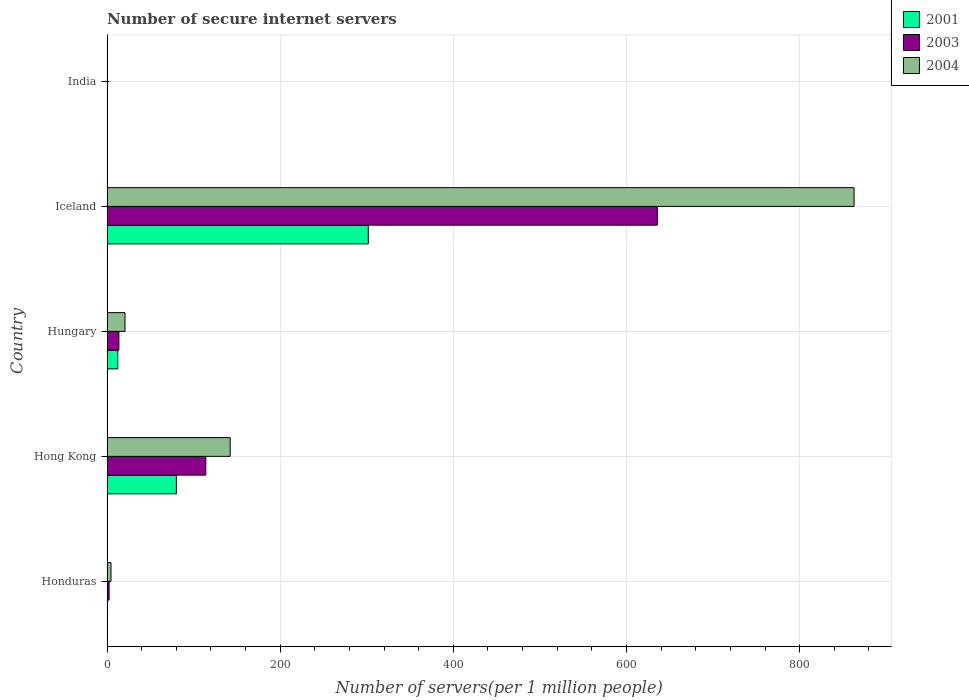Are the number of bars per tick equal to the number of legend labels?
Your response must be concise. Yes. Are the number of bars on each tick of the Y-axis equal?
Make the answer very short. Yes. How many bars are there on the 2nd tick from the bottom?
Your response must be concise. 3. What is the label of the 4th group of bars from the top?
Your answer should be very brief. Hong Kong. What is the number of secure internet servers in 2001 in Hong Kong?
Offer a very short reply. 80.13. Across all countries, what is the maximum number of secure internet servers in 2004?
Offer a terse response. 862.8. Across all countries, what is the minimum number of secure internet servers in 2003?
Make the answer very short. 0.25. In which country was the number of secure internet servers in 2003 maximum?
Provide a succinct answer. Iceland. What is the total number of secure internet servers in 2004 in the graph?
Your answer should be very brief. 1030.83. What is the difference between the number of secure internet servers in 2001 in Hungary and that in India?
Provide a short and direct response. 12.35. What is the difference between the number of secure internet servers in 2004 in India and the number of secure internet servers in 2001 in Iceland?
Give a very brief answer. -301.38. What is the average number of secure internet servers in 2004 per country?
Give a very brief answer. 206.17. What is the difference between the number of secure internet servers in 2003 and number of secure internet servers in 2001 in Iceland?
Provide a short and direct response. 333.74. What is the ratio of the number of secure internet servers in 2001 in Honduras to that in Hungary?
Provide a succinct answer. 0.05. What is the difference between the highest and the second highest number of secure internet servers in 2001?
Keep it short and to the point. 221.66. What is the difference between the highest and the lowest number of secure internet servers in 2003?
Your answer should be very brief. 635.28. In how many countries, is the number of secure internet servers in 2001 greater than the average number of secure internet servers in 2001 taken over all countries?
Ensure brevity in your answer.  2. Is it the case that in every country, the sum of the number of secure internet servers in 2003 and number of secure internet servers in 2004 is greater than the number of secure internet servers in 2001?
Keep it short and to the point. Yes. Are all the bars in the graph horizontal?
Offer a terse response. Yes. What is the difference between two consecutive major ticks on the X-axis?
Your answer should be compact. 200. Are the values on the major ticks of X-axis written in scientific E-notation?
Provide a short and direct response. No. Does the graph contain any zero values?
Your answer should be compact. No. Where does the legend appear in the graph?
Your answer should be compact. Top right. How many legend labels are there?
Your answer should be very brief. 3. How are the legend labels stacked?
Offer a terse response. Vertical. What is the title of the graph?
Provide a short and direct response. Number of secure internet servers. Does "1970" appear as one of the legend labels in the graph?
Provide a short and direct response. No. What is the label or title of the X-axis?
Offer a very short reply. Number of servers(per 1 million people). What is the label or title of the Y-axis?
Make the answer very short. Country. What is the Number of servers(per 1 million people) of 2001 in Honduras?
Offer a very short reply. 0.63. What is the Number of servers(per 1 million people) of 2003 in Honduras?
Give a very brief answer. 2.41. What is the Number of servers(per 1 million people) of 2004 in Honduras?
Your answer should be compact. 4.59. What is the Number of servers(per 1 million people) in 2001 in Hong Kong?
Make the answer very short. 80.13. What is the Number of servers(per 1 million people) in 2003 in Hong Kong?
Keep it short and to the point. 114.1. What is the Number of servers(per 1 million people) in 2004 in Hong Kong?
Provide a short and direct response. 142.26. What is the Number of servers(per 1 million people) in 2001 in Hungary?
Your answer should be very brief. 12.47. What is the Number of servers(per 1 million people) of 2003 in Hungary?
Your response must be concise. 13.72. What is the Number of servers(per 1 million people) in 2004 in Hungary?
Make the answer very short. 20.78. What is the Number of servers(per 1 million people) in 2001 in Iceland?
Offer a terse response. 301.79. What is the Number of servers(per 1 million people) in 2003 in Iceland?
Offer a terse response. 635.53. What is the Number of servers(per 1 million people) of 2004 in Iceland?
Your answer should be compact. 862.8. What is the Number of servers(per 1 million people) of 2001 in India?
Offer a terse response. 0.11. What is the Number of servers(per 1 million people) in 2003 in India?
Your response must be concise. 0.25. What is the Number of servers(per 1 million people) of 2004 in India?
Your answer should be compact. 0.41. Across all countries, what is the maximum Number of servers(per 1 million people) of 2001?
Keep it short and to the point. 301.79. Across all countries, what is the maximum Number of servers(per 1 million people) in 2003?
Offer a terse response. 635.53. Across all countries, what is the maximum Number of servers(per 1 million people) in 2004?
Your answer should be compact. 862.8. Across all countries, what is the minimum Number of servers(per 1 million people) of 2001?
Provide a succinct answer. 0.11. Across all countries, what is the minimum Number of servers(per 1 million people) of 2003?
Offer a terse response. 0.25. Across all countries, what is the minimum Number of servers(per 1 million people) in 2004?
Provide a short and direct response. 0.41. What is the total Number of servers(per 1 million people) in 2001 in the graph?
Your response must be concise. 395.12. What is the total Number of servers(per 1 million people) of 2003 in the graph?
Make the answer very short. 766.03. What is the total Number of servers(per 1 million people) of 2004 in the graph?
Provide a short and direct response. 1030.83. What is the difference between the Number of servers(per 1 million people) of 2001 in Honduras and that in Hong Kong?
Ensure brevity in your answer.  -79.5. What is the difference between the Number of servers(per 1 million people) of 2003 in Honduras and that in Hong Kong?
Provide a short and direct response. -111.69. What is the difference between the Number of servers(per 1 million people) in 2004 in Honduras and that in Hong Kong?
Your response must be concise. -137.67. What is the difference between the Number of servers(per 1 million people) in 2001 in Honduras and that in Hungary?
Give a very brief answer. -11.84. What is the difference between the Number of servers(per 1 million people) of 2003 in Honduras and that in Hungary?
Keep it short and to the point. -11.31. What is the difference between the Number of servers(per 1 million people) of 2004 in Honduras and that in Hungary?
Your response must be concise. -16.19. What is the difference between the Number of servers(per 1 million people) of 2001 in Honduras and that in Iceland?
Your answer should be compact. -301.16. What is the difference between the Number of servers(per 1 million people) in 2003 in Honduras and that in Iceland?
Your answer should be compact. -633.12. What is the difference between the Number of servers(per 1 million people) in 2004 in Honduras and that in Iceland?
Offer a very short reply. -858.2. What is the difference between the Number of servers(per 1 million people) in 2001 in Honduras and that in India?
Provide a short and direct response. 0.51. What is the difference between the Number of servers(per 1 million people) of 2003 in Honduras and that in India?
Offer a terse response. 2.16. What is the difference between the Number of servers(per 1 million people) in 2004 in Honduras and that in India?
Your response must be concise. 4.18. What is the difference between the Number of servers(per 1 million people) in 2001 in Hong Kong and that in Hungary?
Your answer should be compact. 67.66. What is the difference between the Number of servers(per 1 million people) of 2003 in Hong Kong and that in Hungary?
Ensure brevity in your answer.  100.38. What is the difference between the Number of servers(per 1 million people) of 2004 in Hong Kong and that in Hungary?
Give a very brief answer. 121.48. What is the difference between the Number of servers(per 1 million people) of 2001 in Hong Kong and that in Iceland?
Give a very brief answer. -221.66. What is the difference between the Number of servers(per 1 million people) in 2003 in Hong Kong and that in Iceland?
Ensure brevity in your answer.  -521.43. What is the difference between the Number of servers(per 1 million people) in 2004 in Hong Kong and that in Iceland?
Provide a succinct answer. -720.54. What is the difference between the Number of servers(per 1 million people) of 2001 in Hong Kong and that in India?
Offer a very short reply. 80.01. What is the difference between the Number of servers(per 1 million people) in 2003 in Hong Kong and that in India?
Ensure brevity in your answer.  113.85. What is the difference between the Number of servers(per 1 million people) of 2004 in Hong Kong and that in India?
Offer a terse response. 141.85. What is the difference between the Number of servers(per 1 million people) in 2001 in Hungary and that in Iceland?
Provide a succinct answer. -289.32. What is the difference between the Number of servers(per 1 million people) in 2003 in Hungary and that in Iceland?
Your response must be concise. -621.81. What is the difference between the Number of servers(per 1 million people) in 2004 in Hungary and that in Iceland?
Give a very brief answer. -842.02. What is the difference between the Number of servers(per 1 million people) in 2001 in Hungary and that in India?
Ensure brevity in your answer.  12.35. What is the difference between the Number of servers(per 1 million people) in 2003 in Hungary and that in India?
Offer a very short reply. 13.47. What is the difference between the Number of servers(per 1 million people) in 2004 in Hungary and that in India?
Ensure brevity in your answer.  20.37. What is the difference between the Number of servers(per 1 million people) in 2001 in Iceland and that in India?
Make the answer very short. 301.67. What is the difference between the Number of servers(per 1 million people) of 2003 in Iceland and that in India?
Offer a very short reply. 635.28. What is the difference between the Number of servers(per 1 million people) in 2004 in Iceland and that in India?
Provide a short and direct response. 862.38. What is the difference between the Number of servers(per 1 million people) of 2001 in Honduras and the Number of servers(per 1 million people) of 2003 in Hong Kong?
Provide a succinct answer. -113.47. What is the difference between the Number of servers(per 1 million people) in 2001 in Honduras and the Number of servers(per 1 million people) in 2004 in Hong Kong?
Offer a terse response. -141.63. What is the difference between the Number of servers(per 1 million people) of 2003 in Honduras and the Number of servers(per 1 million people) of 2004 in Hong Kong?
Make the answer very short. -139.84. What is the difference between the Number of servers(per 1 million people) of 2001 in Honduras and the Number of servers(per 1 million people) of 2003 in Hungary?
Provide a succinct answer. -13.09. What is the difference between the Number of servers(per 1 million people) of 2001 in Honduras and the Number of servers(per 1 million people) of 2004 in Hungary?
Keep it short and to the point. -20.15. What is the difference between the Number of servers(per 1 million people) of 2003 in Honduras and the Number of servers(per 1 million people) of 2004 in Hungary?
Make the answer very short. -18.36. What is the difference between the Number of servers(per 1 million people) of 2001 in Honduras and the Number of servers(per 1 million people) of 2003 in Iceland?
Give a very brief answer. -634.9. What is the difference between the Number of servers(per 1 million people) in 2001 in Honduras and the Number of servers(per 1 million people) in 2004 in Iceland?
Provide a succinct answer. -862.17. What is the difference between the Number of servers(per 1 million people) in 2003 in Honduras and the Number of servers(per 1 million people) in 2004 in Iceland?
Offer a very short reply. -860.38. What is the difference between the Number of servers(per 1 million people) of 2001 in Honduras and the Number of servers(per 1 million people) of 2003 in India?
Your answer should be compact. 0.37. What is the difference between the Number of servers(per 1 million people) in 2001 in Honduras and the Number of servers(per 1 million people) in 2004 in India?
Provide a short and direct response. 0.22. What is the difference between the Number of servers(per 1 million people) in 2003 in Honduras and the Number of servers(per 1 million people) in 2004 in India?
Provide a short and direct response. 2. What is the difference between the Number of servers(per 1 million people) of 2001 in Hong Kong and the Number of servers(per 1 million people) of 2003 in Hungary?
Offer a very short reply. 66.41. What is the difference between the Number of servers(per 1 million people) in 2001 in Hong Kong and the Number of servers(per 1 million people) in 2004 in Hungary?
Your response must be concise. 59.35. What is the difference between the Number of servers(per 1 million people) in 2003 in Hong Kong and the Number of servers(per 1 million people) in 2004 in Hungary?
Your answer should be very brief. 93.33. What is the difference between the Number of servers(per 1 million people) of 2001 in Hong Kong and the Number of servers(per 1 million people) of 2003 in Iceland?
Make the answer very short. -555.4. What is the difference between the Number of servers(per 1 million people) of 2001 in Hong Kong and the Number of servers(per 1 million people) of 2004 in Iceland?
Offer a terse response. -782.67. What is the difference between the Number of servers(per 1 million people) in 2003 in Hong Kong and the Number of servers(per 1 million people) in 2004 in Iceland?
Your response must be concise. -748.69. What is the difference between the Number of servers(per 1 million people) in 2001 in Hong Kong and the Number of servers(per 1 million people) in 2003 in India?
Your answer should be very brief. 79.87. What is the difference between the Number of servers(per 1 million people) of 2001 in Hong Kong and the Number of servers(per 1 million people) of 2004 in India?
Offer a terse response. 79.72. What is the difference between the Number of servers(per 1 million people) of 2003 in Hong Kong and the Number of servers(per 1 million people) of 2004 in India?
Offer a very short reply. 113.69. What is the difference between the Number of servers(per 1 million people) in 2001 in Hungary and the Number of servers(per 1 million people) in 2003 in Iceland?
Your answer should be very brief. -623.07. What is the difference between the Number of servers(per 1 million people) of 2001 in Hungary and the Number of servers(per 1 million people) of 2004 in Iceland?
Offer a terse response. -850.33. What is the difference between the Number of servers(per 1 million people) in 2003 in Hungary and the Number of servers(per 1 million people) in 2004 in Iceland?
Your response must be concise. -849.07. What is the difference between the Number of servers(per 1 million people) of 2001 in Hungary and the Number of servers(per 1 million people) of 2003 in India?
Give a very brief answer. 12.21. What is the difference between the Number of servers(per 1 million people) of 2001 in Hungary and the Number of servers(per 1 million people) of 2004 in India?
Your answer should be very brief. 12.06. What is the difference between the Number of servers(per 1 million people) in 2003 in Hungary and the Number of servers(per 1 million people) in 2004 in India?
Your response must be concise. 13.31. What is the difference between the Number of servers(per 1 million people) of 2001 in Iceland and the Number of servers(per 1 million people) of 2003 in India?
Offer a very short reply. 301.53. What is the difference between the Number of servers(per 1 million people) of 2001 in Iceland and the Number of servers(per 1 million people) of 2004 in India?
Provide a short and direct response. 301.38. What is the difference between the Number of servers(per 1 million people) in 2003 in Iceland and the Number of servers(per 1 million people) in 2004 in India?
Make the answer very short. 635.12. What is the average Number of servers(per 1 million people) of 2001 per country?
Offer a terse response. 79.02. What is the average Number of servers(per 1 million people) of 2003 per country?
Provide a succinct answer. 153.21. What is the average Number of servers(per 1 million people) in 2004 per country?
Ensure brevity in your answer.  206.17. What is the difference between the Number of servers(per 1 million people) in 2001 and Number of servers(per 1 million people) in 2003 in Honduras?
Offer a terse response. -1.79. What is the difference between the Number of servers(per 1 million people) of 2001 and Number of servers(per 1 million people) of 2004 in Honduras?
Offer a very short reply. -3.96. What is the difference between the Number of servers(per 1 million people) of 2003 and Number of servers(per 1 million people) of 2004 in Honduras?
Your answer should be compact. -2.18. What is the difference between the Number of servers(per 1 million people) in 2001 and Number of servers(per 1 million people) in 2003 in Hong Kong?
Offer a terse response. -33.97. What is the difference between the Number of servers(per 1 million people) in 2001 and Number of servers(per 1 million people) in 2004 in Hong Kong?
Provide a short and direct response. -62.13. What is the difference between the Number of servers(per 1 million people) in 2003 and Number of servers(per 1 million people) in 2004 in Hong Kong?
Offer a very short reply. -28.15. What is the difference between the Number of servers(per 1 million people) in 2001 and Number of servers(per 1 million people) in 2003 in Hungary?
Provide a succinct answer. -1.26. What is the difference between the Number of servers(per 1 million people) in 2001 and Number of servers(per 1 million people) in 2004 in Hungary?
Your response must be concise. -8.31. What is the difference between the Number of servers(per 1 million people) in 2003 and Number of servers(per 1 million people) in 2004 in Hungary?
Ensure brevity in your answer.  -7.06. What is the difference between the Number of servers(per 1 million people) in 2001 and Number of servers(per 1 million people) in 2003 in Iceland?
Make the answer very short. -333.74. What is the difference between the Number of servers(per 1 million people) in 2001 and Number of servers(per 1 million people) in 2004 in Iceland?
Make the answer very short. -561.01. What is the difference between the Number of servers(per 1 million people) in 2003 and Number of servers(per 1 million people) in 2004 in Iceland?
Make the answer very short. -227.26. What is the difference between the Number of servers(per 1 million people) in 2001 and Number of servers(per 1 million people) in 2003 in India?
Offer a terse response. -0.14. What is the difference between the Number of servers(per 1 million people) of 2001 and Number of servers(per 1 million people) of 2004 in India?
Provide a succinct answer. -0.3. What is the difference between the Number of servers(per 1 million people) in 2003 and Number of servers(per 1 million people) in 2004 in India?
Your answer should be compact. -0.16. What is the ratio of the Number of servers(per 1 million people) in 2001 in Honduras to that in Hong Kong?
Your answer should be very brief. 0.01. What is the ratio of the Number of servers(per 1 million people) of 2003 in Honduras to that in Hong Kong?
Your answer should be compact. 0.02. What is the ratio of the Number of servers(per 1 million people) of 2004 in Honduras to that in Hong Kong?
Ensure brevity in your answer.  0.03. What is the ratio of the Number of servers(per 1 million people) in 2001 in Honduras to that in Hungary?
Provide a succinct answer. 0.05. What is the ratio of the Number of servers(per 1 million people) of 2003 in Honduras to that in Hungary?
Keep it short and to the point. 0.18. What is the ratio of the Number of servers(per 1 million people) in 2004 in Honduras to that in Hungary?
Your response must be concise. 0.22. What is the ratio of the Number of servers(per 1 million people) in 2001 in Honduras to that in Iceland?
Keep it short and to the point. 0. What is the ratio of the Number of servers(per 1 million people) of 2003 in Honduras to that in Iceland?
Your answer should be compact. 0. What is the ratio of the Number of servers(per 1 million people) in 2004 in Honduras to that in Iceland?
Make the answer very short. 0.01. What is the ratio of the Number of servers(per 1 million people) in 2001 in Honduras to that in India?
Give a very brief answer. 5.52. What is the ratio of the Number of servers(per 1 million people) in 2003 in Honduras to that in India?
Offer a terse response. 9.52. What is the ratio of the Number of servers(per 1 million people) in 2004 in Honduras to that in India?
Keep it short and to the point. 11.19. What is the ratio of the Number of servers(per 1 million people) of 2001 in Hong Kong to that in Hungary?
Offer a very short reply. 6.43. What is the ratio of the Number of servers(per 1 million people) in 2003 in Hong Kong to that in Hungary?
Your answer should be compact. 8.32. What is the ratio of the Number of servers(per 1 million people) in 2004 in Hong Kong to that in Hungary?
Offer a terse response. 6.85. What is the ratio of the Number of servers(per 1 million people) in 2001 in Hong Kong to that in Iceland?
Ensure brevity in your answer.  0.27. What is the ratio of the Number of servers(per 1 million people) in 2003 in Hong Kong to that in Iceland?
Provide a succinct answer. 0.18. What is the ratio of the Number of servers(per 1 million people) of 2004 in Hong Kong to that in Iceland?
Provide a short and direct response. 0.16. What is the ratio of the Number of servers(per 1 million people) of 2001 in Hong Kong to that in India?
Offer a terse response. 704. What is the ratio of the Number of servers(per 1 million people) of 2003 in Hong Kong to that in India?
Your answer should be very brief. 450.06. What is the ratio of the Number of servers(per 1 million people) of 2004 in Hong Kong to that in India?
Provide a succinct answer. 346.84. What is the ratio of the Number of servers(per 1 million people) of 2001 in Hungary to that in Iceland?
Your answer should be compact. 0.04. What is the ratio of the Number of servers(per 1 million people) in 2003 in Hungary to that in Iceland?
Provide a short and direct response. 0.02. What is the ratio of the Number of servers(per 1 million people) of 2004 in Hungary to that in Iceland?
Give a very brief answer. 0.02. What is the ratio of the Number of servers(per 1 million people) of 2001 in Hungary to that in India?
Provide a succinct answer. 109.53. What is the ratio of the Number of servers(per 1 million people) of 2003 in Hungary to that in India?
Your response must be concise. 54.13. What is the ratio of the Number of servers(per 1 million people) in 2004 in Hungary to that in India?
Offer a very short reply. 50.66. What is the ratio of the Number of servers(per 1 million people) in 2001 in Iceland to that in India?
Your response must be concise. 2651.5. What is the ratio of the Number of servers(per 1 million people) in 2003 in Iceland to that in India?
Keep it short and to the point. 2506.78. What is the ratio of the Number of servers(per 1 million people) in 2004 in Iceland to that in India?
Give a very brief answer. 2103.61. What is the difference between the highest and the second highest Number of servers(per 1 million people) of 2001?
Keep it short and to the point. 221.66. What is the difference between the highest and the second highest Number of servers(per 1 million people) in 2003?
Provide a succinct answer. 521.43. What is the difference between the highest and the second highest Number of servers(per 1 million people) of 2004?
Keep it short and to the point. 720.54. What is the difference between the highest and the lowest Number of servers(per 1 million people) of 2001?
Your answer should be compact. 301.67. What is the difference between the highest and the lowest Number of servers(per 1 million people) in 2003?
Keep it short and to the point. 635.28. What is the difference between the highest and the lowest Number of servers(per 1 million people) of 2004?
Offer a very short reply. 862.38. 